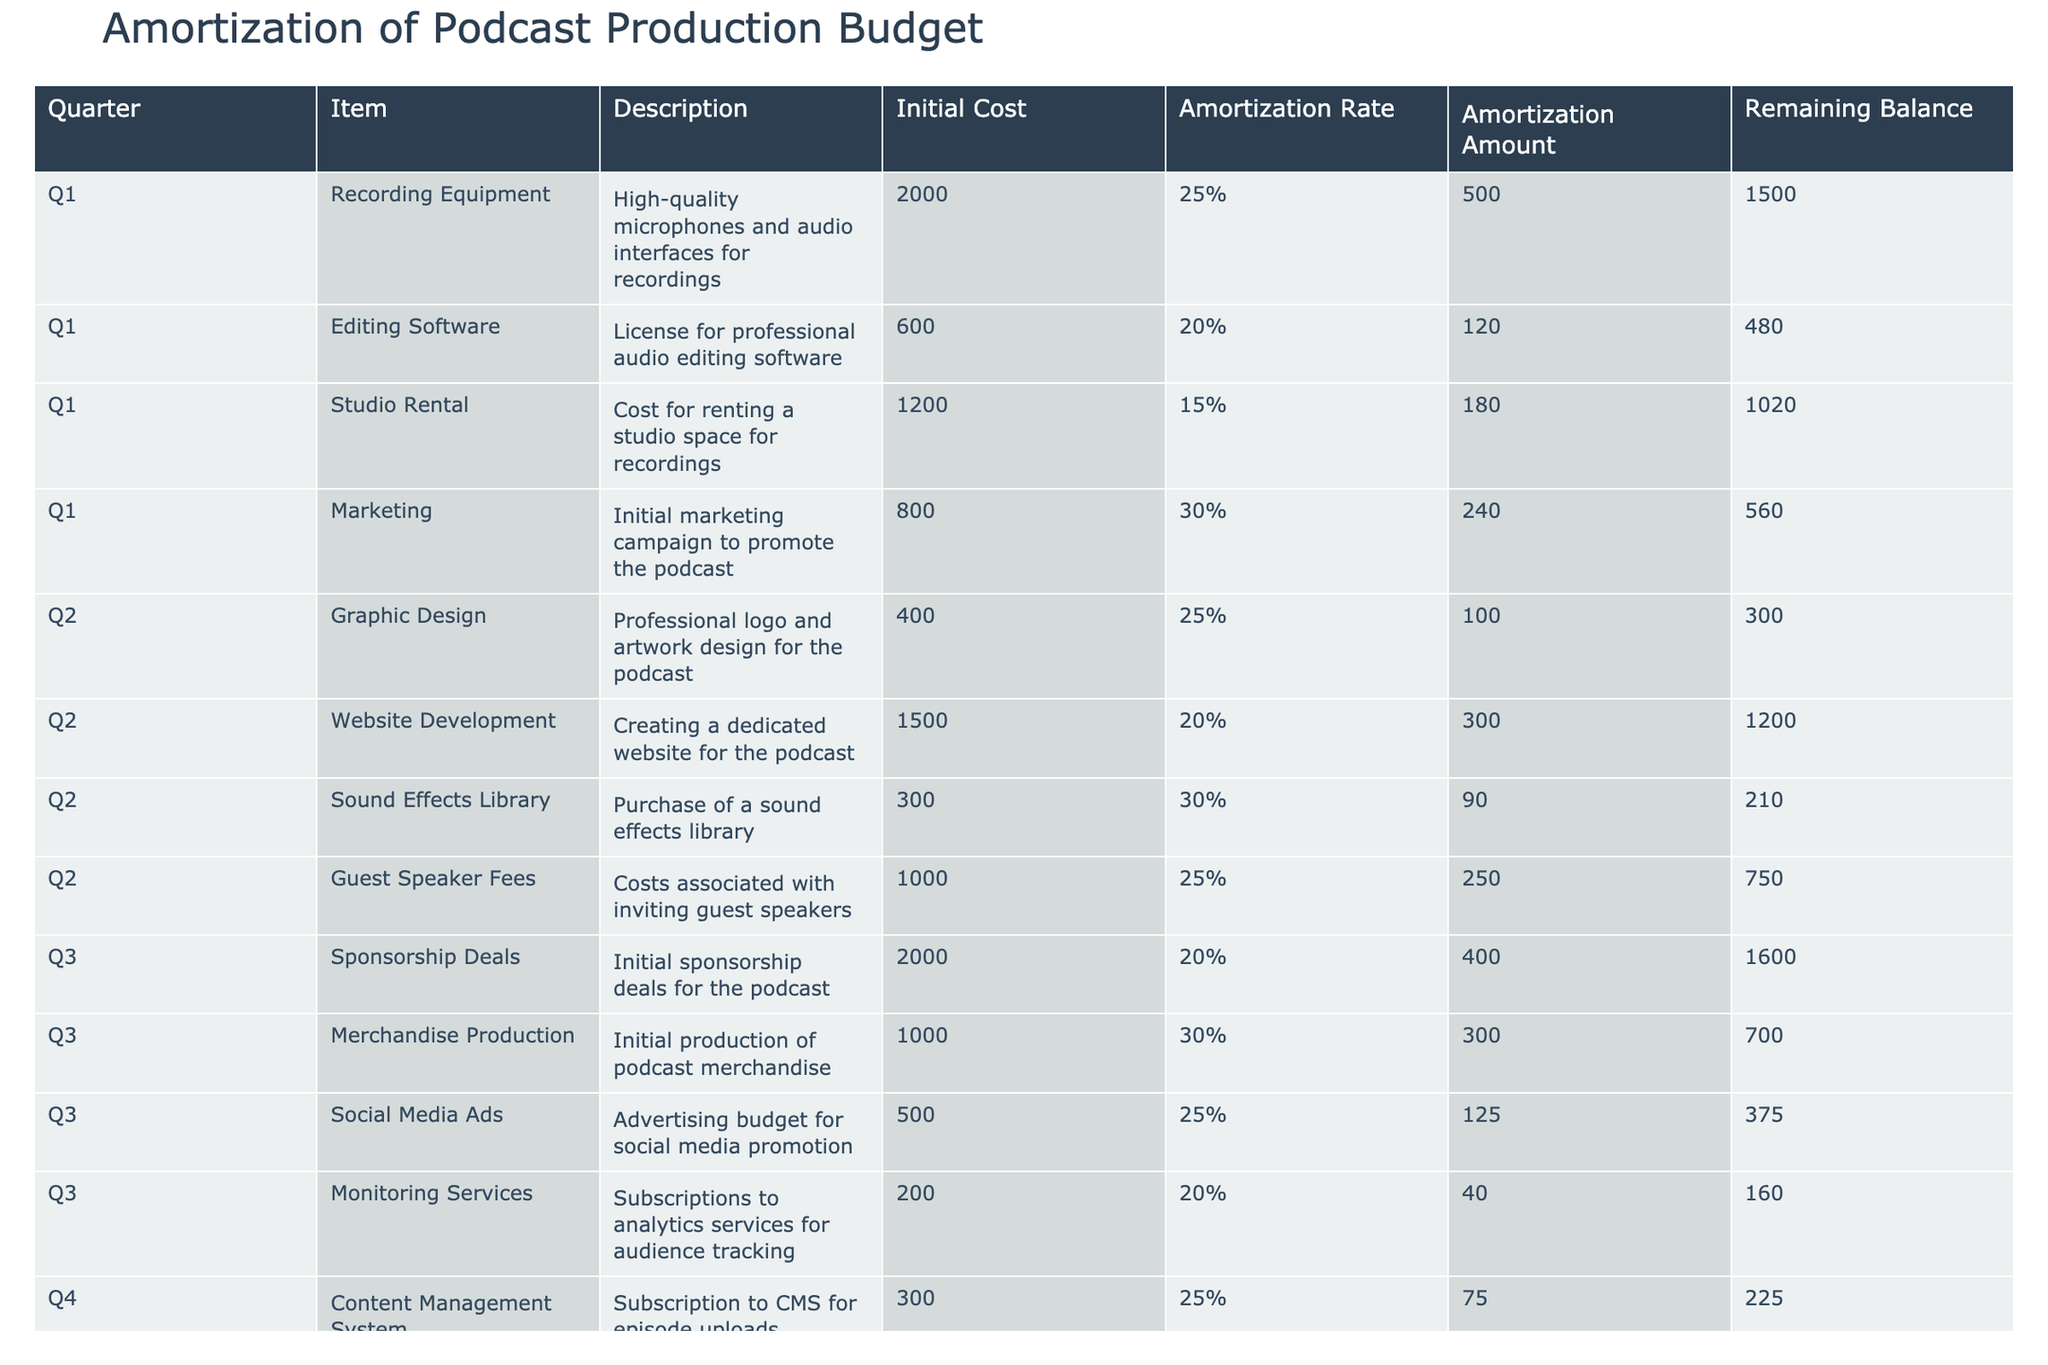What is the total initial cost of podcast production items in Q1? The initial costs for Q1 are: Recording Equipment (2000), Editing Software (600), Studio Rental (1200), and Marketing (800). Adding these amounts together gives us 2000 + 600 + 1200 + 800 = 3600.
Answer: 3600 Which item in Q2 has the highest remaining balance? The remaining balances for Q2 items are: Graphic Design (300), Website Development (1200), Sound Effects Library (210), and Guest Speaker Fees (750). The highest amount is 1200 for Website Development.
Answer: 1200 What percentage of the initial cost of the Marketing item in Q1 is the amortization amount? The initial cost for Marketing is 800, and the amortization amount is 240. To find the percentage, we use the formula (240 / 800) * 100, which equals 30%.
Answer: 30% Is the total amortization amount for Q3 higher than for Q2? The total amortization for Q2 is calculated by adding the amounts: 100 (Graphic Design) + 300 (Website Development) + 90 (Sound Effects Library) + 250 (Guest Speaker Fees) = 740. For Q3, we have 400 (Sponsorship Deals) + 300 (Merchandise Production) + 125 (Social Media Ads) + 40 (Monitoring Services) = 865. Since 865 is greater than 740, the answer is yes.
Answer: Yes What is the average amortization amount for all items in Q4? The items in Q4 are: Content Management System (75), Legal Services (140), Audience Engagement Activities (180), and Depreciation of Equipment (300). To find the average, we sum these amounts: 75 + 140 + 180 + 300 = 695, and then divide by the number of items (4). Thus, the average is 695 / 4 = 173.75.
Answer: 173.75 Which quarter had the lowest initial cost for its items? Summing the initial costs for each quarter, we find: Q1 = 2000 + 600 + 1200 + 800 = 3600, Q2 = 400 + 1500 + 300 + 1000 = 2200, Q3 = 2000 + 1000 + 500 + 200 = 3700, and Q4 = 300 + 700 + 600 + 2000 = 3600. The lowest is Q2 with a total of 2200.
Answer: Q2 How much total remaining balance is left for all items in Q1? The remaining balances for Q1 items are: 1500 (Recording Equipment), 480 (Editing Software), 1020 (Studio Rental), and 560 (Marketing). Summing these gives 1500 + 480 + 1020 + 560 = 3560.
Answer: 3560 Is the amortization rate for Guest Speaker Fees in Q2 lower than for Social Media Ads in Q3? The amortization rate for Guest Speaker Fees (Q2) is 25% and for Social Media Ads (Q3) is 25% as well. Since both rates are the same, the answer is no.
Answer: No What is the total remaining balance for all items across all quarters? Adding up the remaining balances across all quarters: Q1 - 1500 + 480 + 1020 + 560 = 3560, Q2 - 300 + 1200 + 210 + 750 = 1460, Q3 - 1600 + 700 + 375 + 160 = 2835, and Q4 - 225 + 560 + 420 + 1200 = 2405. Now, summing all the totals: 3560 + 1460 + 2835 + 2405 = 11260.
Answer: 11260 